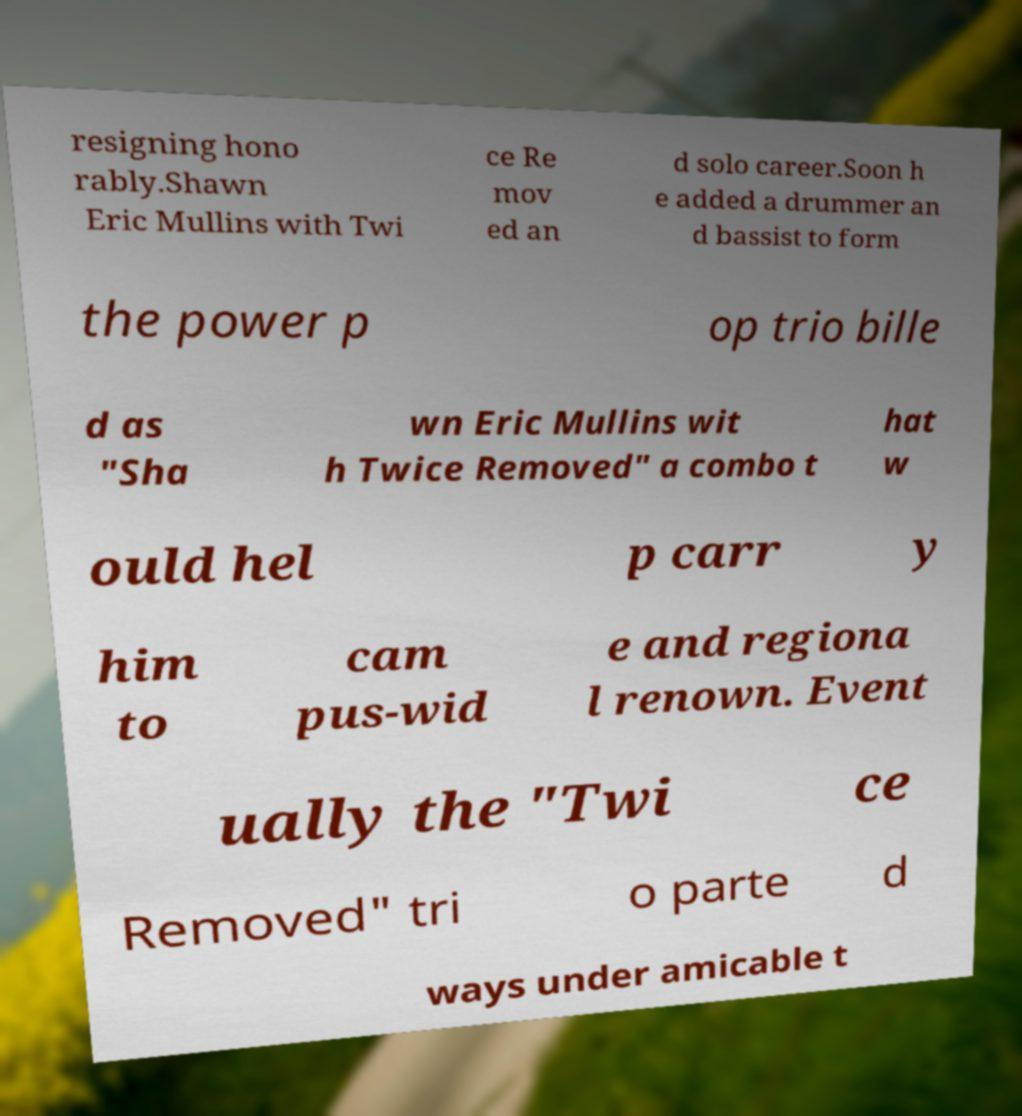I need the written content from this picture converted into text. Can you do that? resigning hono rably.Shawn Eric Mullins with Twi ce Re mov ed an d solo career.Soon h e added a drummer an d bassist to form the power p op trio bille d as "Sha wn Eric Mullins wit h Twice Removed" a combo t hat w ould hel p carr y him to cam pus-wid e and regiona l renown. Event ually the "Twi ce Removed" tri o parte d ways under amicable t 